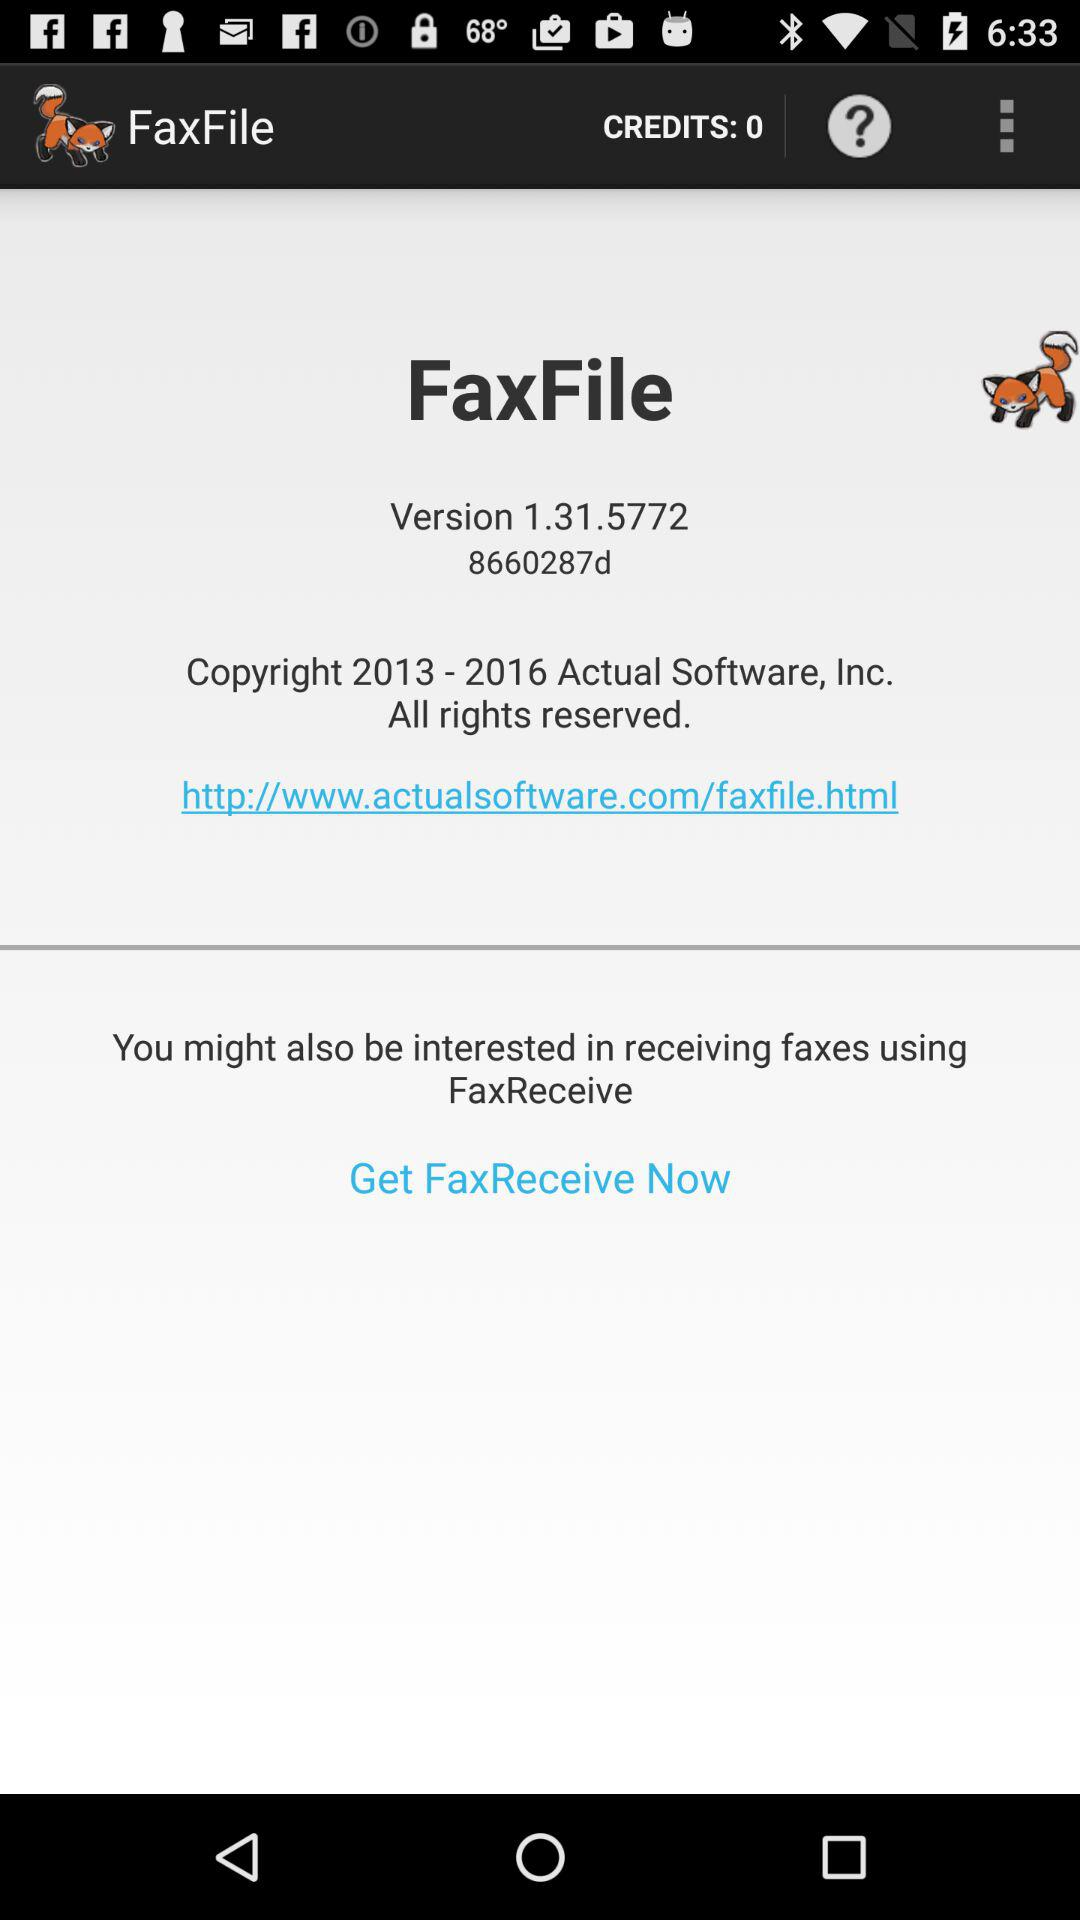What is the version of "FaxFile"? The version is 1.31.5772. 